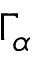<formula> <loc_0><loc_0><loc_500><loc_500>\Gamma _ { \alpha }</formula> 